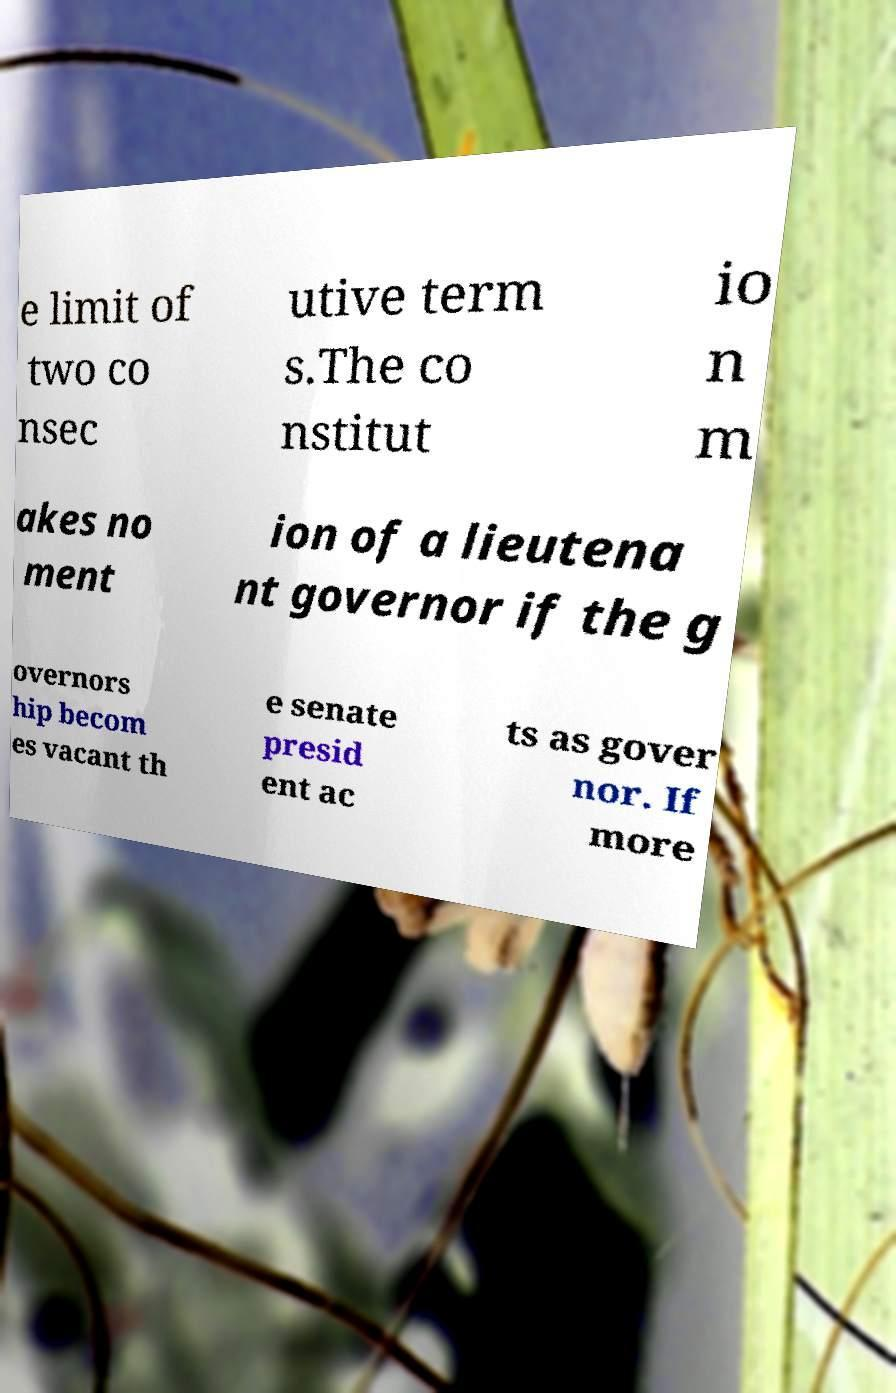I need the written content from this picture converted into text. Can you do that? e limit of two co nsec utive term s.The co nstitut io n m akes no ment ion of a lieutena nt governor if the g overnors hip becom es vacant th e senate presid ent ac ts as gover nor. If more 